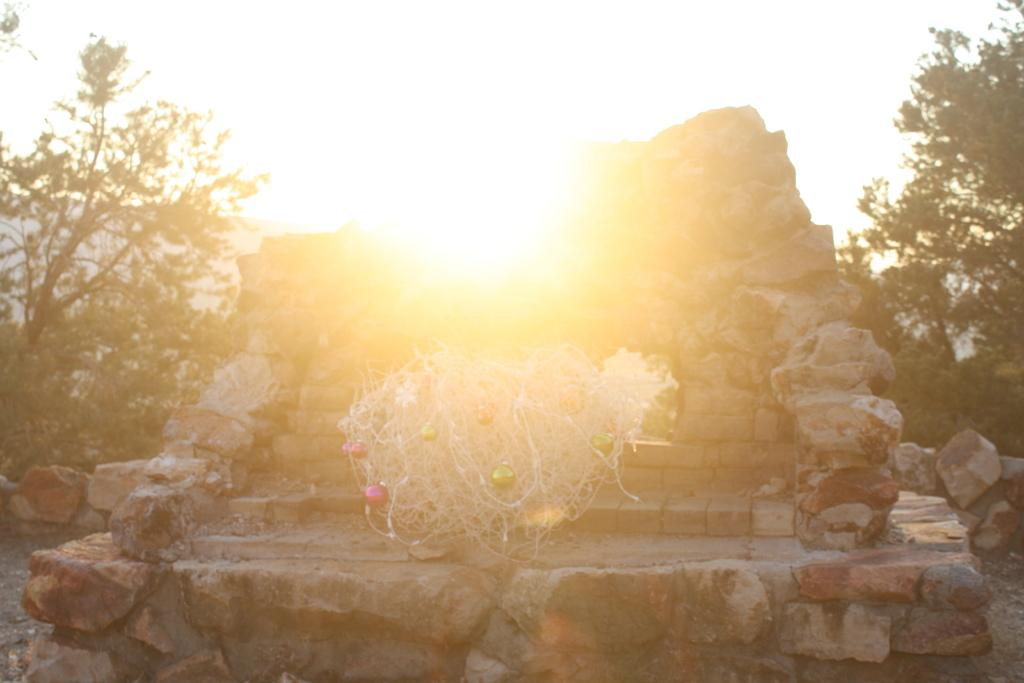What type of steps can be seen in the front of the image? There are rock steps in the front of the image. What can be seen in the background of the image? There are trees in the back of the image. What is visible in the sky in the image? The sky is visible in the image, and the sun is present. Is there a trail for skating in the image? There is no trail for skating present in the image. Can you see a stop sign in the image? There is no stop sign visible in the image. 